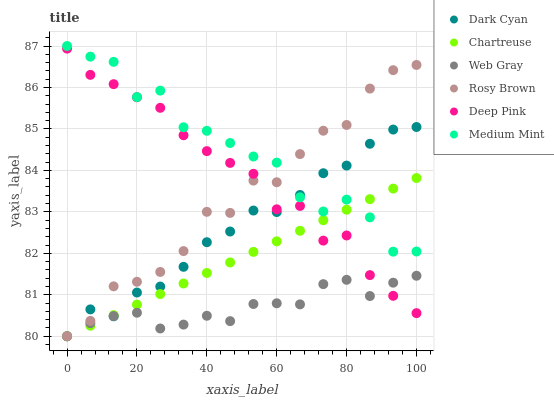Does Web Gray have the minimum area under the curve?
Answer yes or no. Yes. Does Medium Mint have the maximum area under the curve?
Answer yes or no. Yes. Does Rosy Brown have the minimum area under the curve?
Answer yes or no. No. Does Rosy Brown have the maximum area under the curve?
Answer yes or no. No. Is Chartreuse the smoothest?
Answer yes or no. Yes. Is Medium Mint the roughest?
Answer yes or no. Yes. Is Web Gray the smoothest?
Answer yes or no. No. Is Web Gray the roughest?
Answer yes or no. No. Does Web Gray have the lowest value?
Answer yes or no. Yes. Does Deep Pink have the lowest value?
Answer yes or no. No. Does Medium Mint have the highest value?
Answer yes or no. Yes. Does Rosy Brown have the highest value?
Answer yes or no. No. Is Deep Pink less than Medium Mint?
Answer yes or no. Yes. Is Medium Mint greater than Web Gray?
Answer yes or no. Yes. Does Rosy Brown intersect Deep Pink?
Answer yes or no. Yes. Is Rosy Brown less than Deep Pink?
Answer yes or no. No. Is Rosy Brown greater than Deep Pink?
Answer yes or no. No. Does Deep Pink intersect Medium Mint?
Answer yes or no. No. 